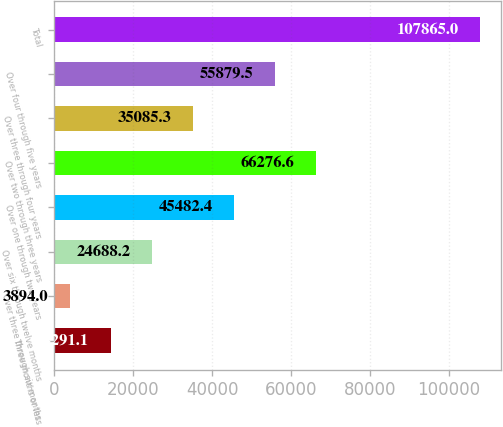<chart> <loc_0><loc_0><loc_500><loc_500><bar_chart><fcel>Three months or less<fcel>Over three through six months<fcel>Over six through twelve months<fcel>Over one through two years<fcel>Over two through three years<fcel>Over three through four years<fcel>Over four through five years<fcel>Total<nl><fcel>14291.1<fcel>3894<fcel>24688.2<fcel>45482.4<fcel>66276.6<fcel>35085.3<fcel>55879.5<fcel>107865<nl></chart> 